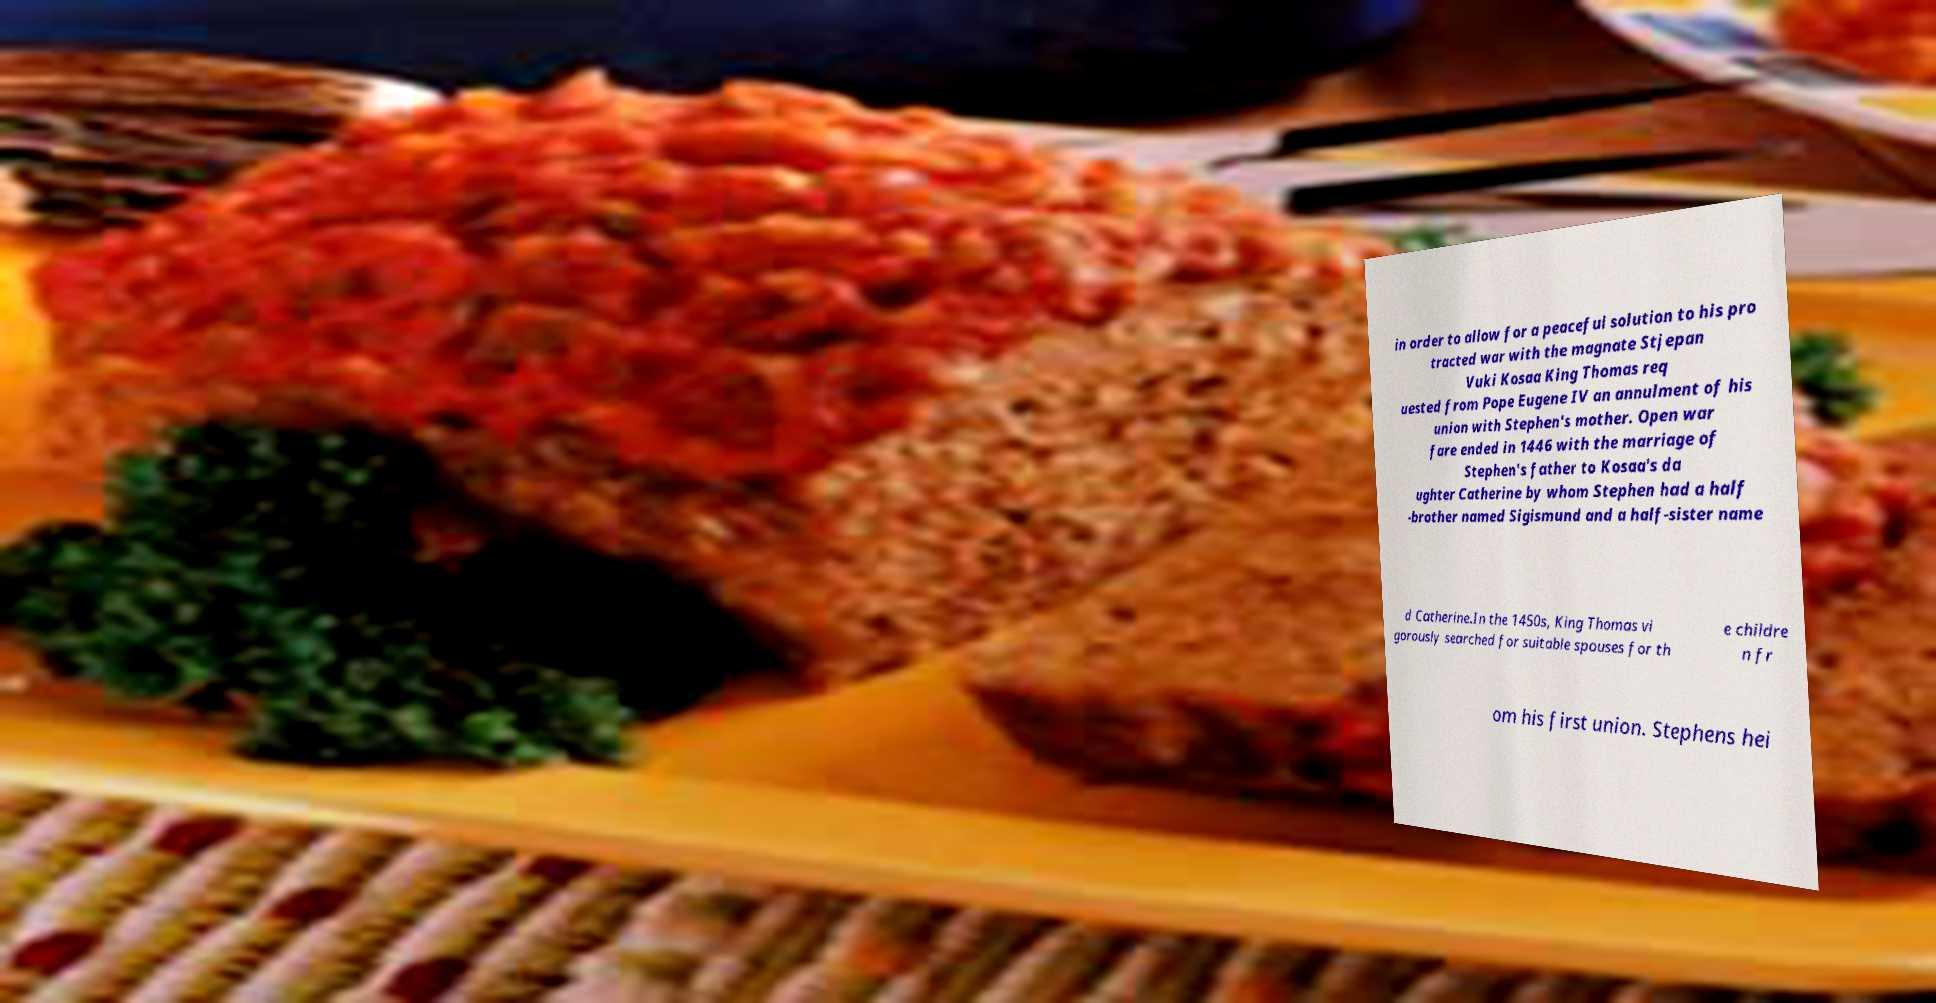There's text embedded in this image that I need extracted. Can you transcribe it verbatim? in order to allow for a peaceful solution to his pro tracted war with the magnate Stjepan Vuki Kosaa King Thomas req uested from Pope Eugene IV an annulment of his union with Stephen's mother. Open war fare ended in 1446 with the marriage of Stephen's father to Kosaa's da ughter Catherine by whom Stephen had a half -brother named Sigismund and a half-sister name d Catherine.In the 1450s, King Thomas vi gorously searched for suitable spouses for th e childre n fr om his first union. Stephens hei 